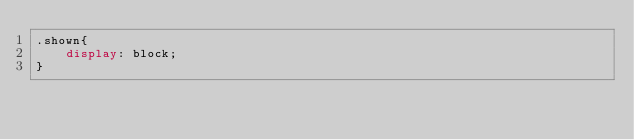<code> <loc_0><loc_0><loc_500><loc_500><_CSS_>.shown{
	display: block;
}</code> 